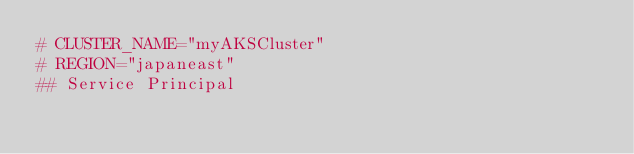Convert code to text. <code><loc_0><loc_0><loc_500><loc_500><_Bash_># CLUSTER_NAME="myAKSCluster"
# REGION="japaneast"
## Service Principal</code> 